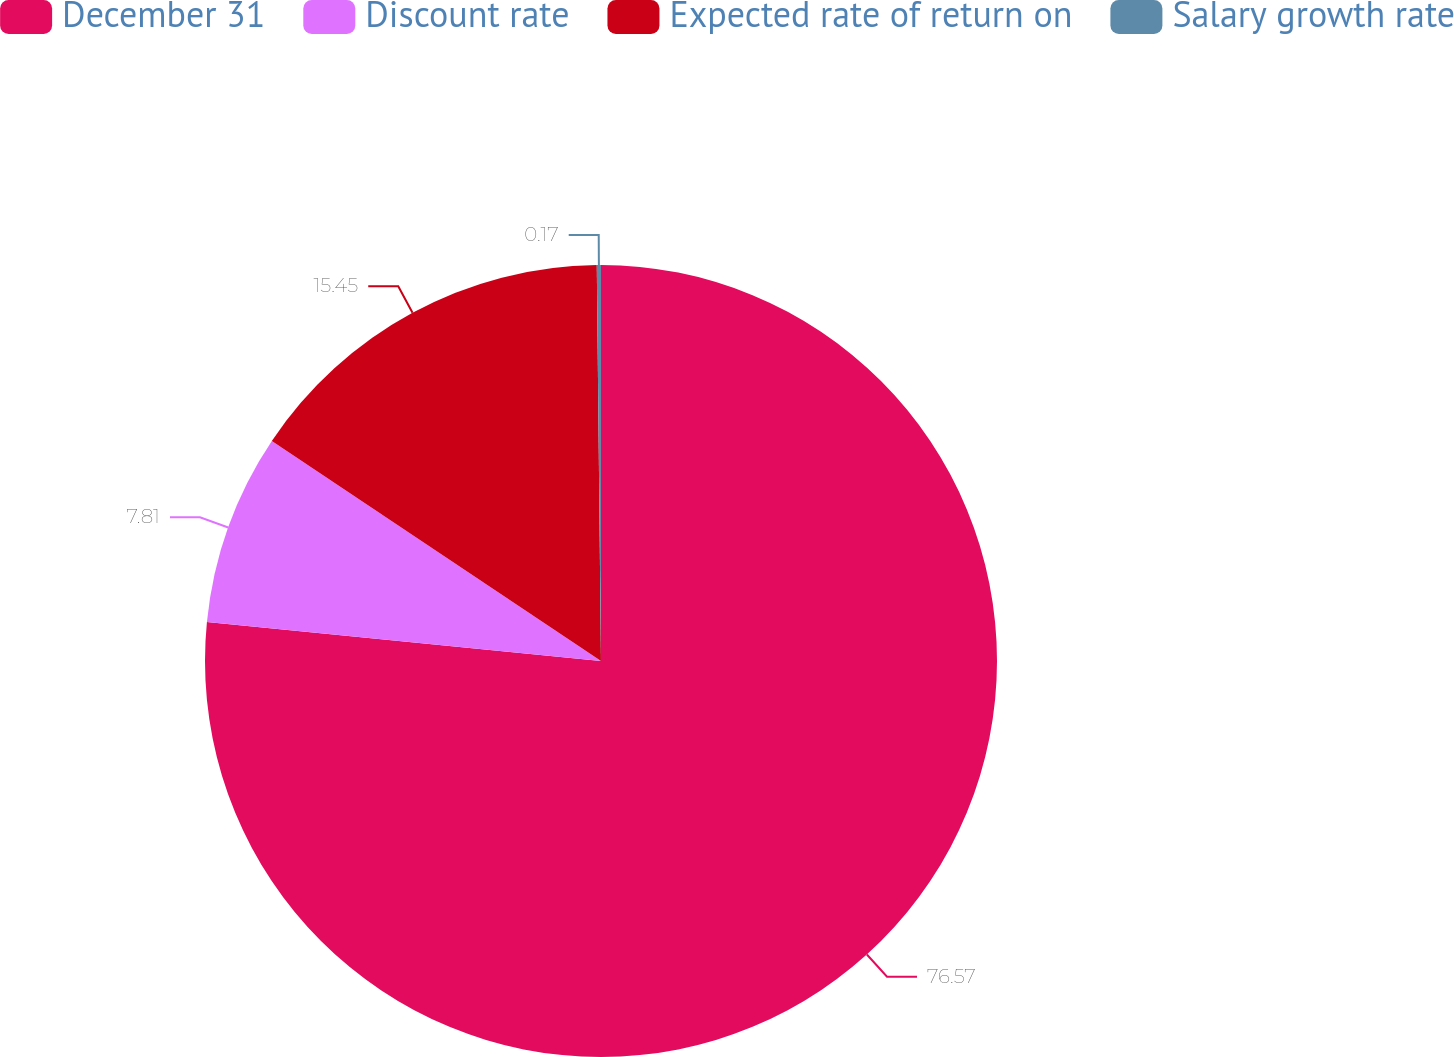Convert chart. <chart><loc_0><loc_0><loc_500><loc_500><pie_chart><fcel>December 31<fcel>Discount rate<fcel>Expected rate of return on<fcel>Salary growth rate<nl><fcel>76.57%<fcel>7.81%<fcel>15.45%<fcel>0.17%<nl></chart> 